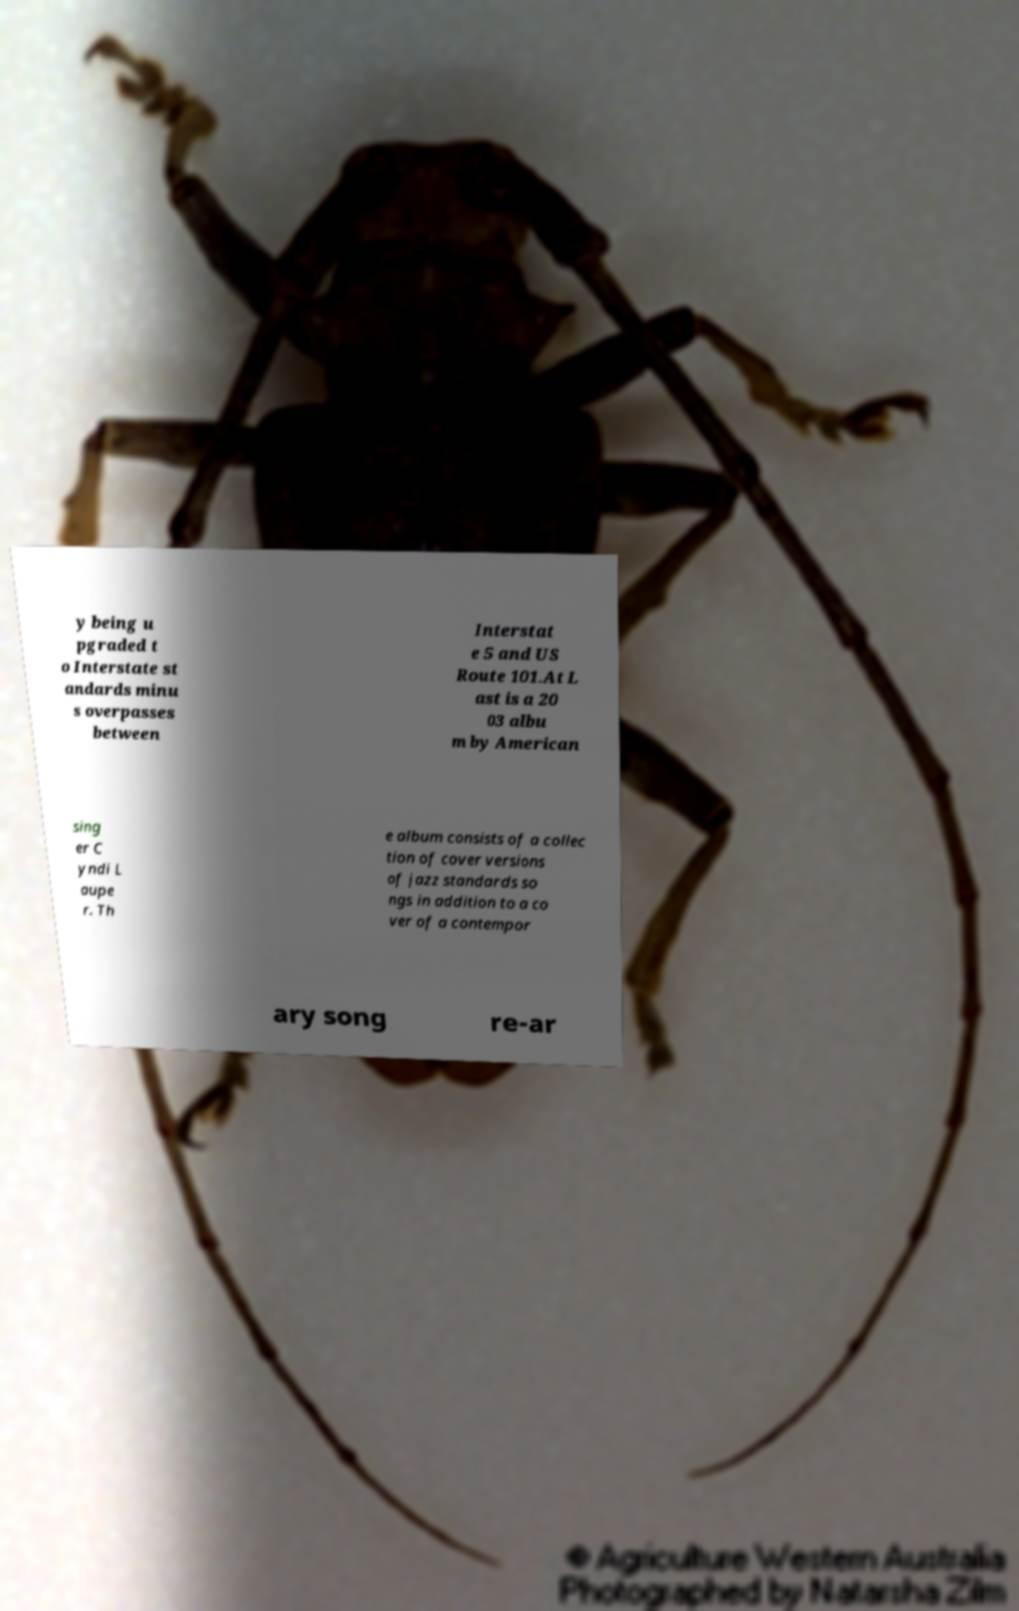Can you accurately transcribe the text from the provided image for me? y being u pgraded t o Interstate st andards minu s overpasses between Interstat e 5 and US Route 101.At L ast is a 20 03 albu m by American sing er C yndi L aupe r. Th e album consists of a collec tion of cover versions of jazz standards so ngs in addition to a co ver of a contempor ary song re-ar 